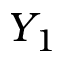Convert formula to latex. <formula><loc_0><loc_0><loc_500><loc_500>Y _ { 1 }</formula> 